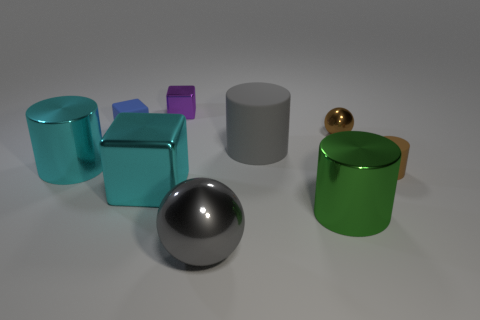Are the objects arranged in any particular pattern? The objects appear to be arranged randomly on the surface. There is no discernible pattern in their arrangement, but they're spaced out in a way that each object is distinct and not overlapping with others, possibly to showcase their shapes and colors. 